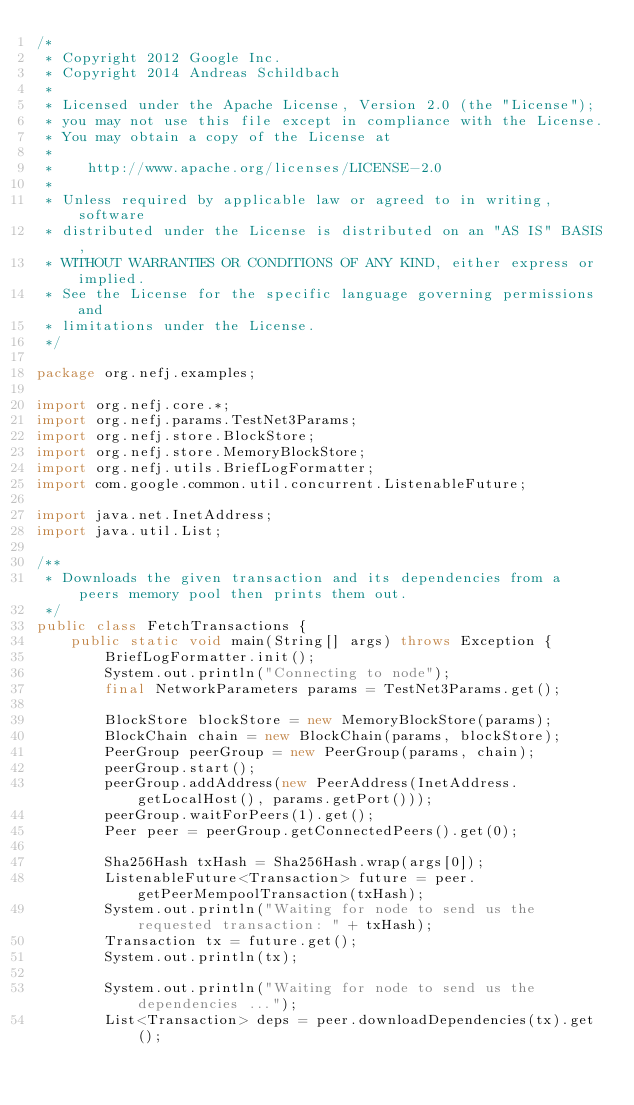<code> <loc_0><loc_0><loc_500><loc_500><_Java_>/*
 * Copyright 2012 Google Inc.
 * Copyright 2014 Andreas Schildbach
 *
 * Licensed under the Apache License, Version 2.0 (the "License");
 * you may not use this file except in compliance with the License.
 * You may obtain a copy of the License at
 *
 *    http://www.apache.org/licenses/LICENSE-2.0
 *
 * Unless required by applicable law or agreed to in writing, software
 * distributed under the License is distributed on an "AS IS" BASIS,
 * WITHOUT WARRANTIES OR CONDITIONS OF ANY KIND, either express or implied.
 * See the License for the specific language governing permissions and
 * limitations under the License.
 */

package org.nefj.examples;

import org.nefj.core.*;
import org.nefj.params.TestNet3Params;
import org.nefj.store.BlockStore;
import org.nefj.store.MemoryBlockStore;
import org.nefj.utils.BriefLogFormatter;
import com.google.common.util.concurrent.ListenableFuture;

import java.net.InetAddress;
import java.util.List;

/**
 * Downloads the given transaction and its dependencies from a peers memory pool then prints them out.
 */
public class FetchTransactions {
    public static void main(String[] args) throws Exception {
        BriefLogFormatter.init();
        System.out.println("Connecting to node");
        final NetworkParameters params = TestNet3Params.get();

        BlockStore blockStore = new MemoryBlockStore(params);
        BlockChain chain = new BlockChain(params, blockStore);
        PeerGroup peerGroup = new PeerGroup(params, chain);
        peerGroup.start();
        peerGroup.addAddress(new PeerAddress(InetAddress.getLocalHost(), params.getPort()));
        peerGroup.waitForPeers(1).get();
        Peer peer = peerGroup.getConnectedPeers().get(0);

        Sha256Hash txHash = Sha256Hash.wrap(args[0]);
        ListenableFuture<Transaction> future = peer.getPeerMempoolTransaction(txHash);
        System.out.println("Waiting for node to send us the requested transaction: " + txHash);
        Transaction tx = future.get();
        System.out.println(tx);

        System.out.println("Waiting for node to send us the dependencies ...");
        List<Transaction> deps = peer.downloadDependencies(tx).get();</code> 